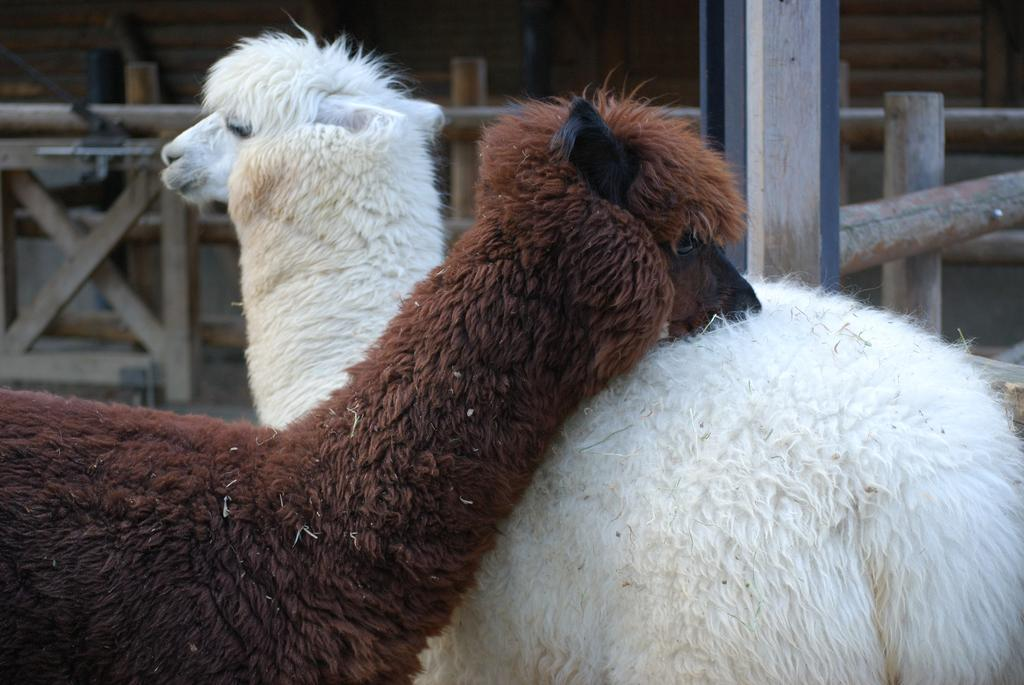How many Llamas are present in the image? There are two Llamas in the image. What are the colors of the Llamas? One Llama is white in color, and the other is brown in color. What can be seen in the background of the image? There is a wooden fence in the image. What type of oil is being used by the Llamas in the image? There is no oil present in the image, as it features two Llamas and a wooden fence. 